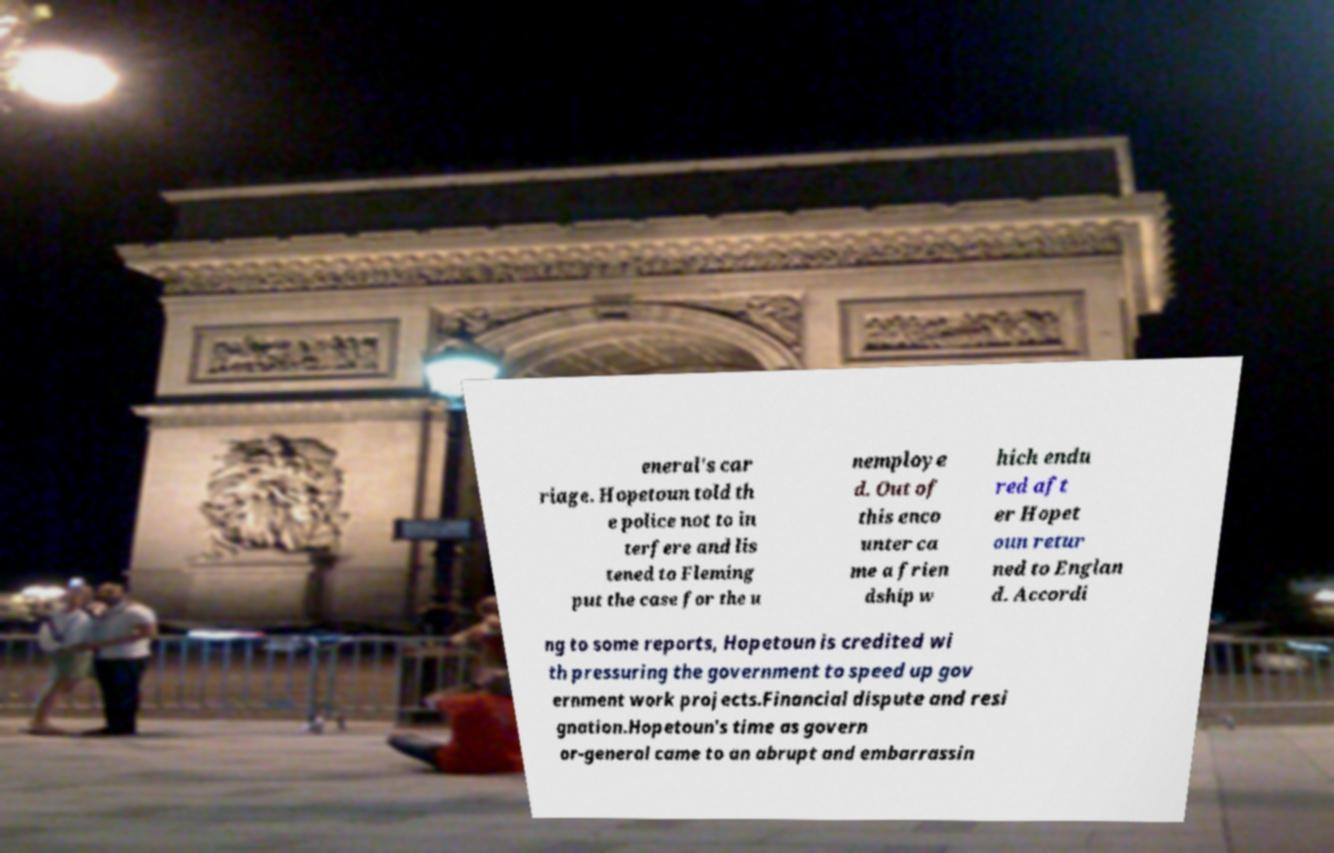Could you assist in decoding the text presented in this image and type it out clearly? eneral's car riage. Hopetoun told th e police not to in terfere and lis tened to Fleming put the case for the u nemploye d. Out of this enco unter ca me a frien dship w hich endu red aft er Hopet oun retur ned to Englan d. Accordi ng to some reports, Hopetoun is credited wi th pressuring the government to speed up gov ernment work projects.Financial dispute and resi gnation.Hopetoun's time as govern or-general came to an abrupt and embarrassin 